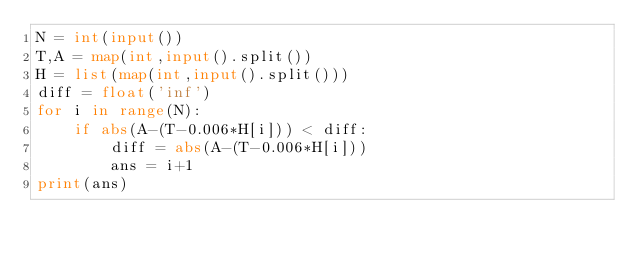Convert code to text. <code><loc_0><loc_0><loc_500><loc_500><_Python_>N = int(input())
T,A = map(int,input().split())
H = list(map(int,input().split()))
diff = float('inf')
for i in range(N):
    if abs(A-(T-0.006*H[i])) < diff:
        diff = abs(A-(T-0.006*H[i]))
        ans = i+1
print(ans)</code> 